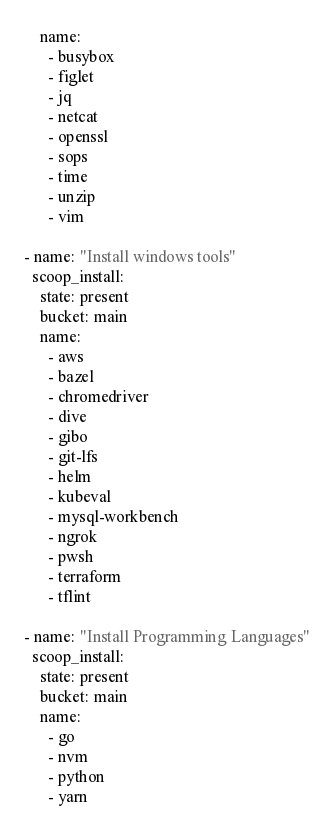Convert code to text. <code><loc_0><loc_0><loc_500><loc_500><_YAML_>    name:
      - busybox
      - figlet
      - jq
      - netcat
      - openssl
      - sops
      - time
      - unzip
      - vim

- name: "Install windows tools"
  scoop_install:
    state: present
    bucket: main
    name:
      - aws
      - bazel
      - chromedriver
      - dive
      - gibo
      - git-lfs
      - helm
      - kubeval
      - mysql-workbench
      - ngrok
      - pwsh
      - terraform
      - tflint

- name: "Install Programming Languages"
  scoop_install:
    state: present
    bucket: main
    name:
      - go
      - nvm
      - python
      - yarn
</code> 